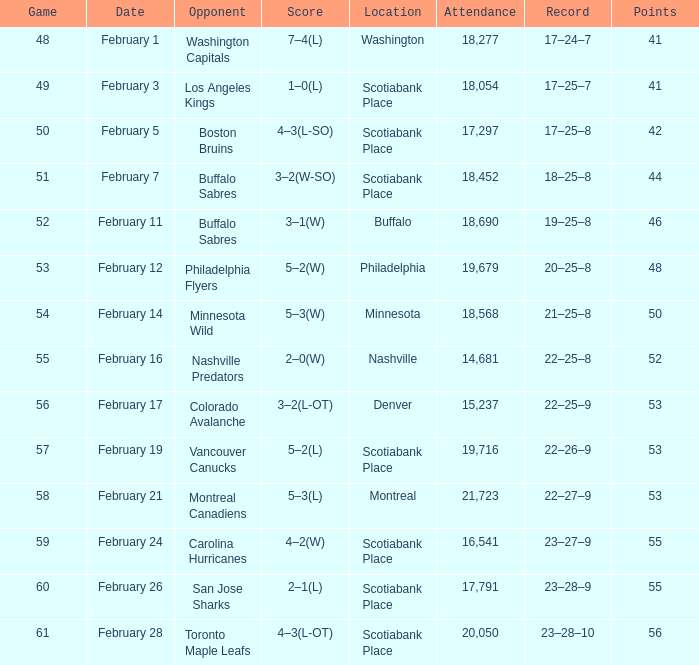What average game was held on february 24 and has an attendance smaller than 16,541? None. 